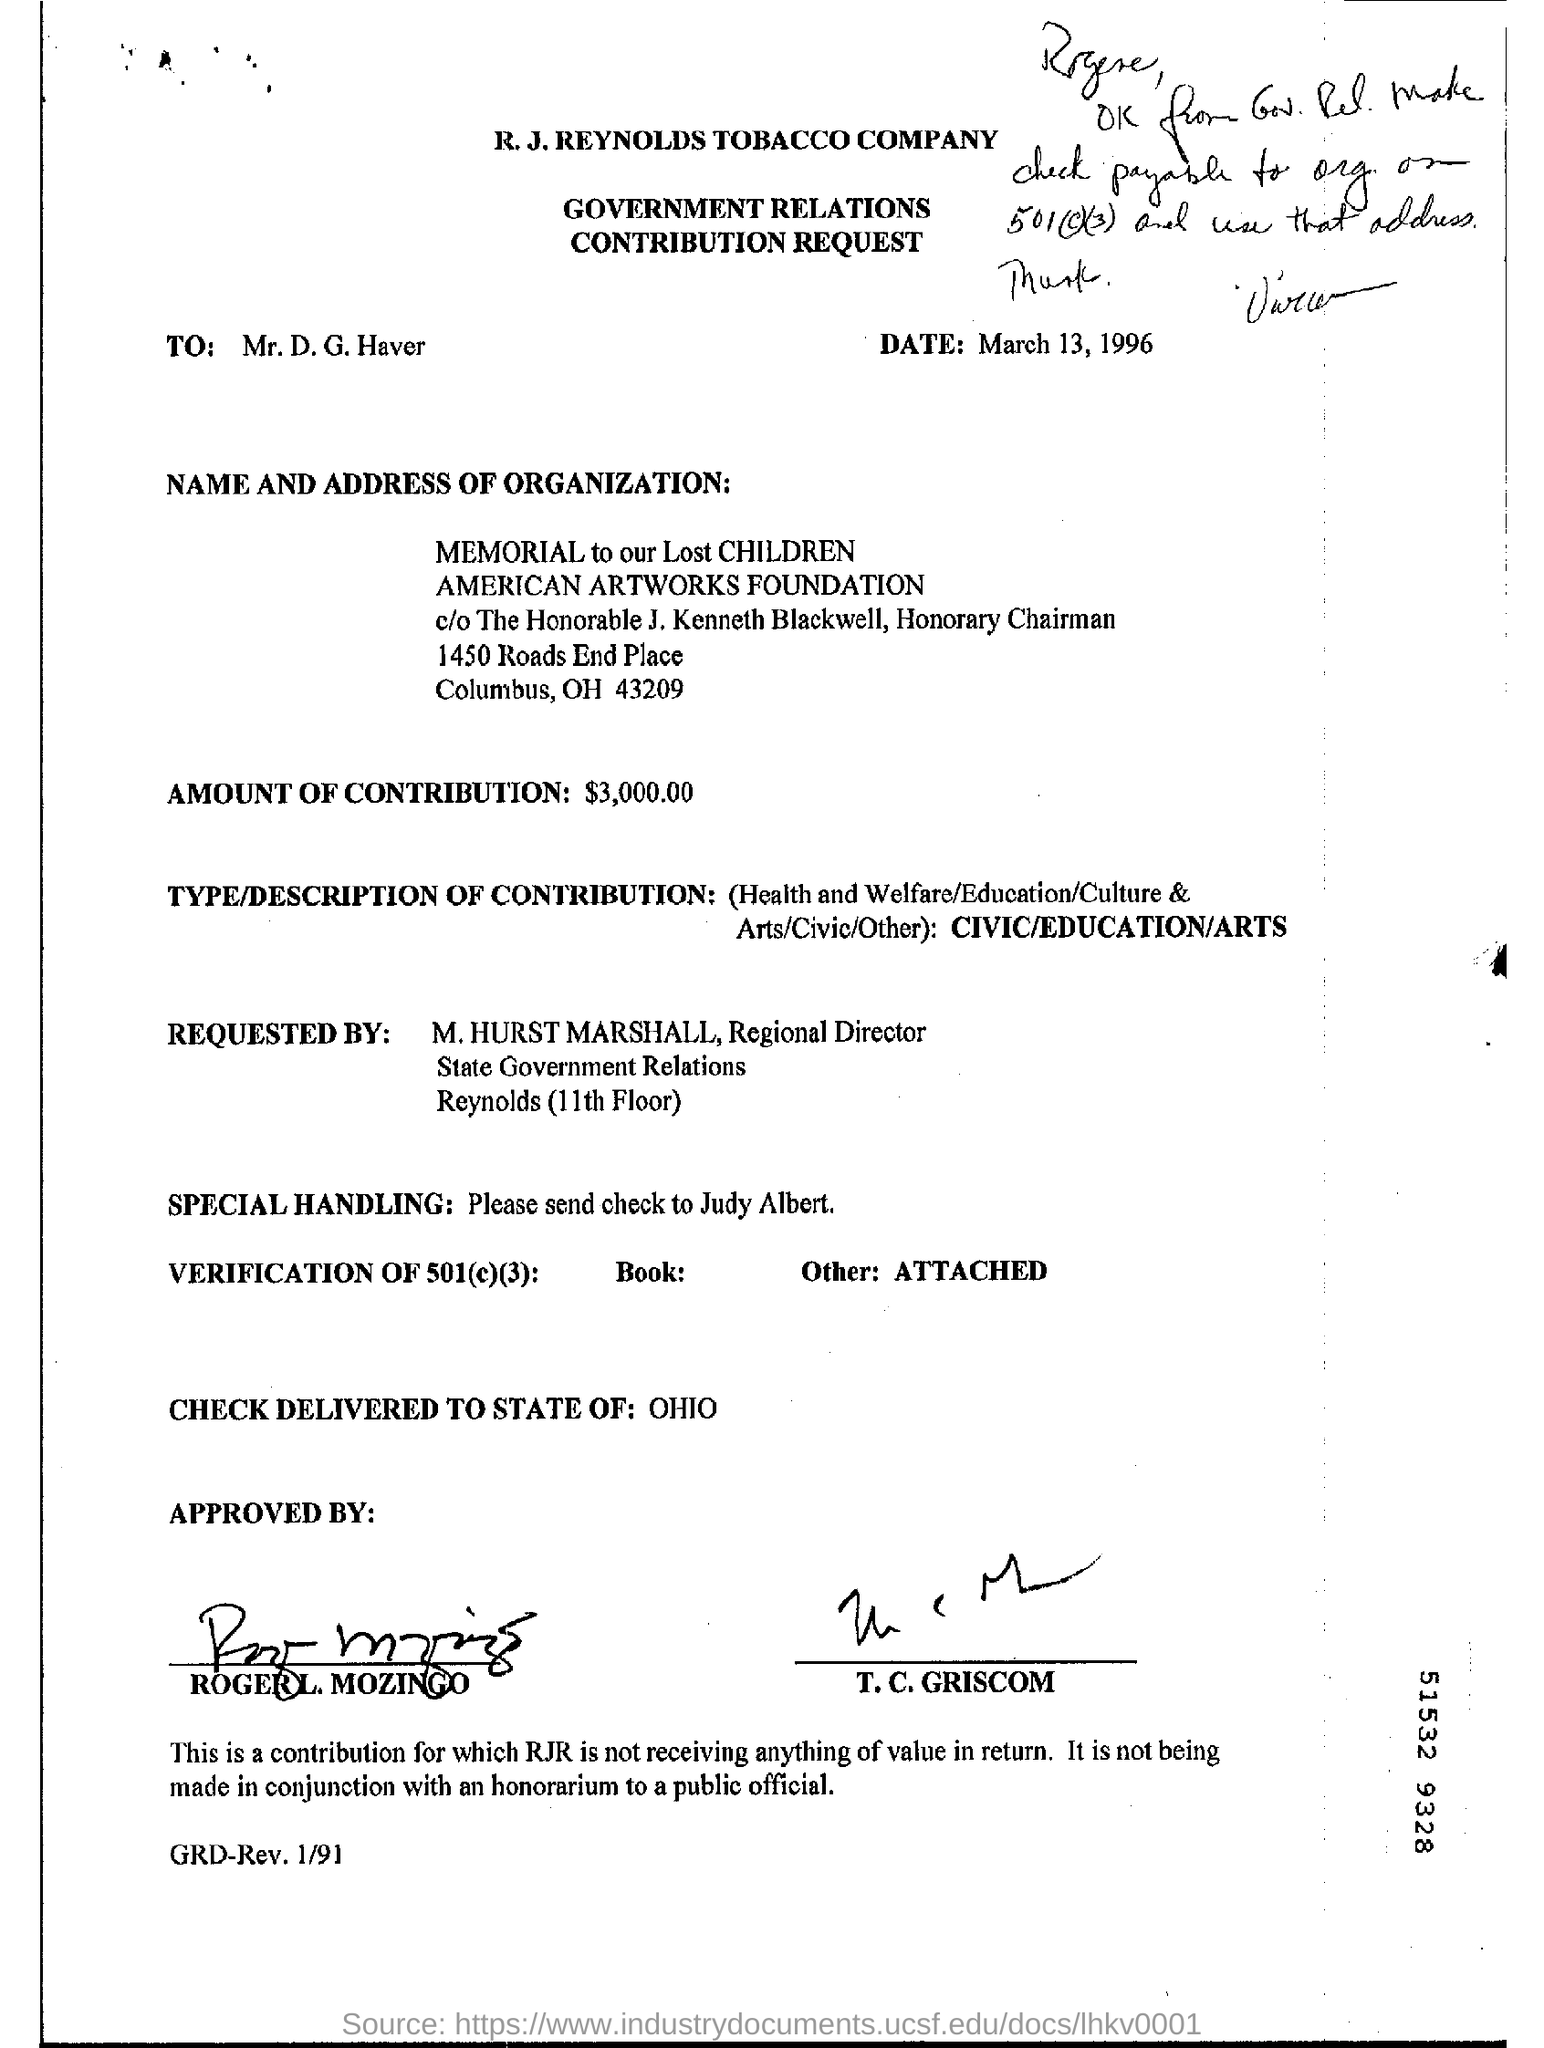List a handful of essential elements in this visual. The postal code for "memorial to our lost children" is 43209. The amount of contribution is $3,000.00. The request is directed to Mr. D.G. Haver. The letter is dated March 13, 1996. The type/description of contribution is CIVIC/EDUCATION/ARTS, which aims to promote civic engagement, education and arts in the community. 